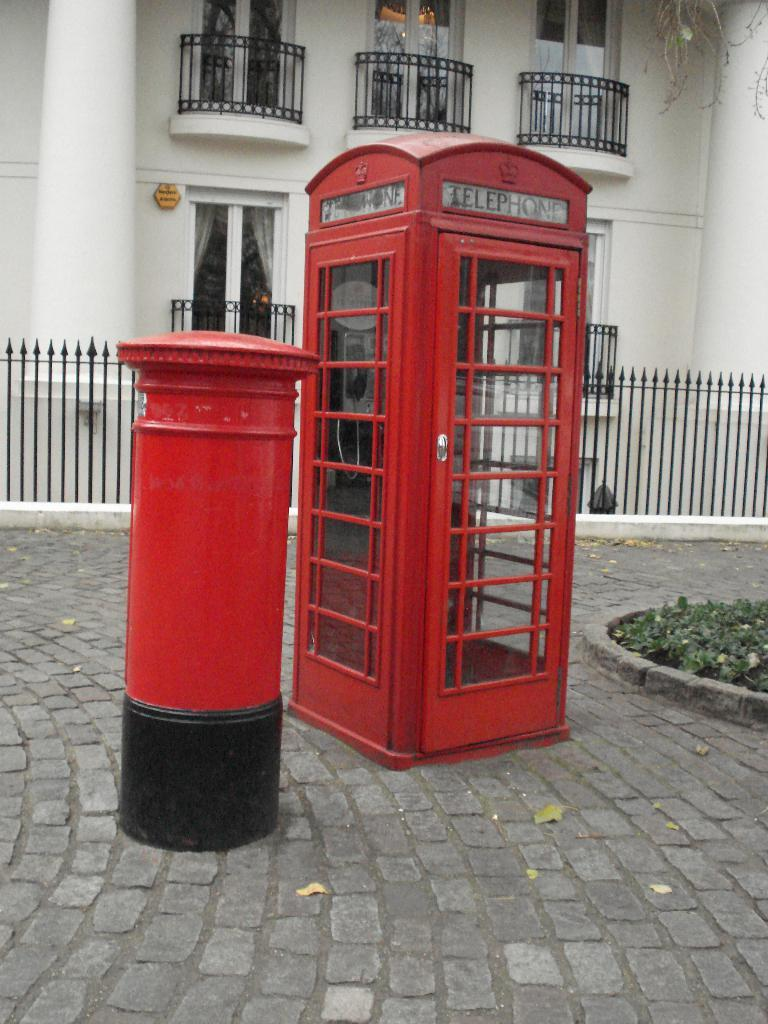<image>
Share a concise interpretation of the image provided. A red phone booth says "telephone" above the door. 